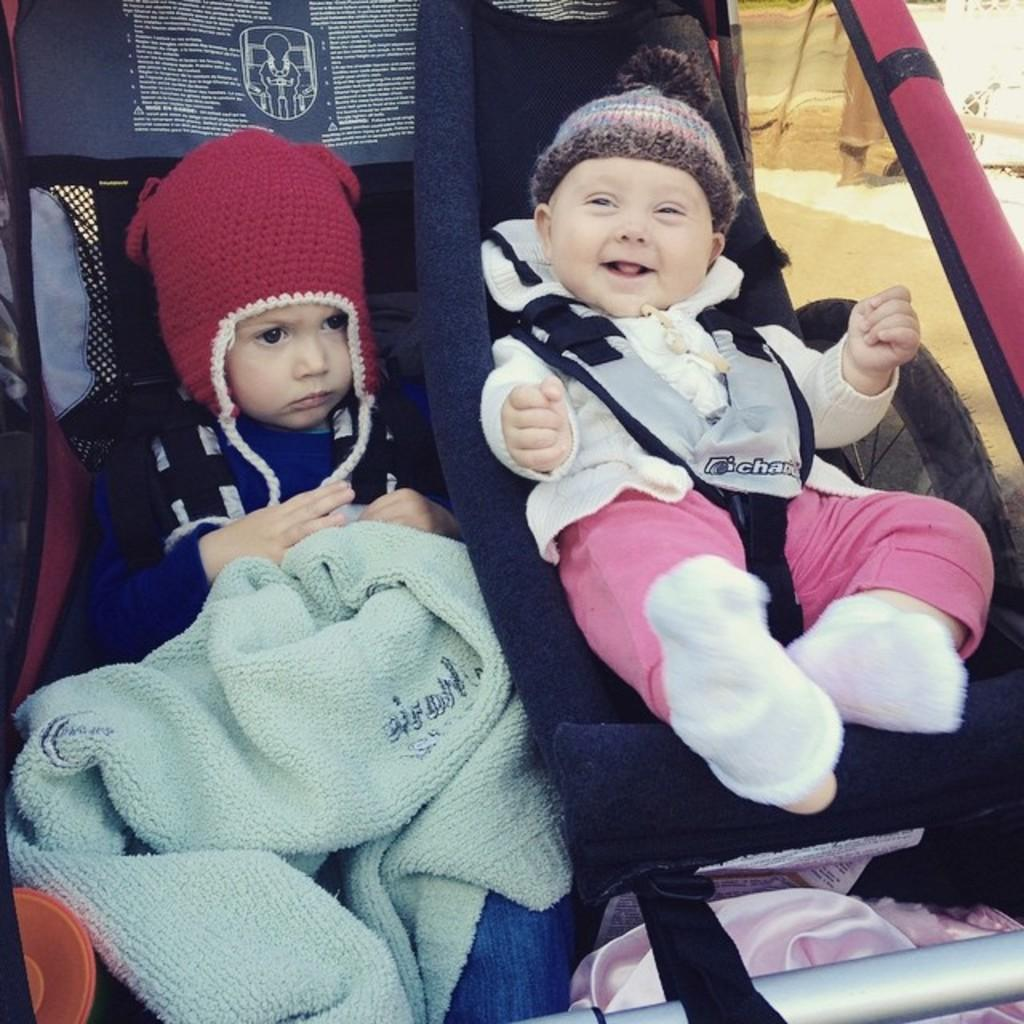How many babies are present in the image? There are two babies in the image. What are the babies wearing? Both babies are wearing a dress and a cap. Where are the babies located in the image? The babies are in a baby carrier. What type of store can be seen in the background of the image? There is no store present in the image; it features two babies in a baby carrier. Can you tell me how deep the quicksand is in the image? There is no quicksand present in the image. 